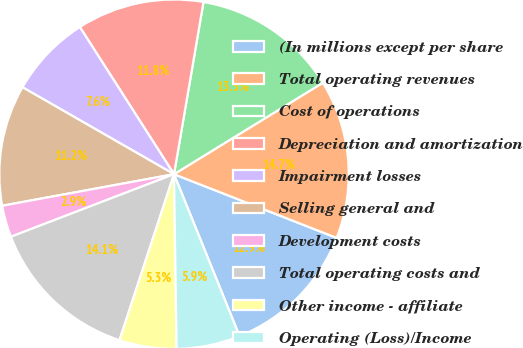<chart> <loc_0><loc_0><loc_500><loc_500><pie_chart><fcel>(In millions except per share<fcel>Total operating revenues<fcel>Cost of operations<fcel>Depreciation and amortization<fcel>Impairment losses<fcel>Selling general and<fcel>Development costs<fcel>Total operating costs and<fcel>Other income - affiliate<fcel>Operating (Loss)/Income<nl><fcel>12.94%<fcel>14.71%<fcel>13.53%<fcel>11.76%<fcel>7.65%<fcel>11.18%<fcel>2.94%<fcel>14.12%<fcel>5.29%<fcel>5.88%<nl></chart> 